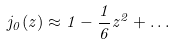Convert formula to latex. <formula><loc_0><loc_0><loc_500><loc_500>j _ { 0 } ( z ) \approx 1 - \frac { 1 } { 6 } z ^ { 2 } + \dots</formula> 